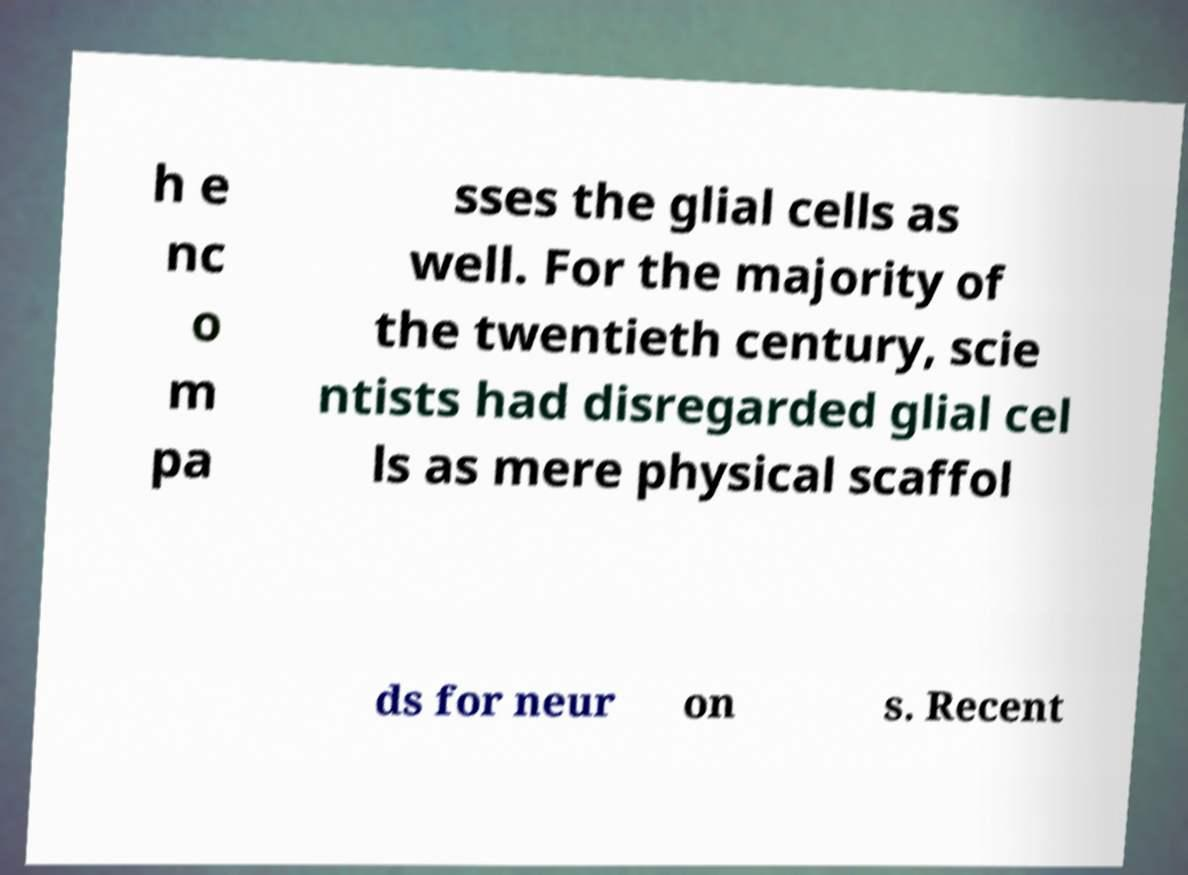Please identify and transcribe the text found in this image. h e nc o m pa sses the glial cells as well. For the majority of the twentieth century, scie ntists had disregarded glial cel ls as mere physical scaffol ds for neur on s. Recent 